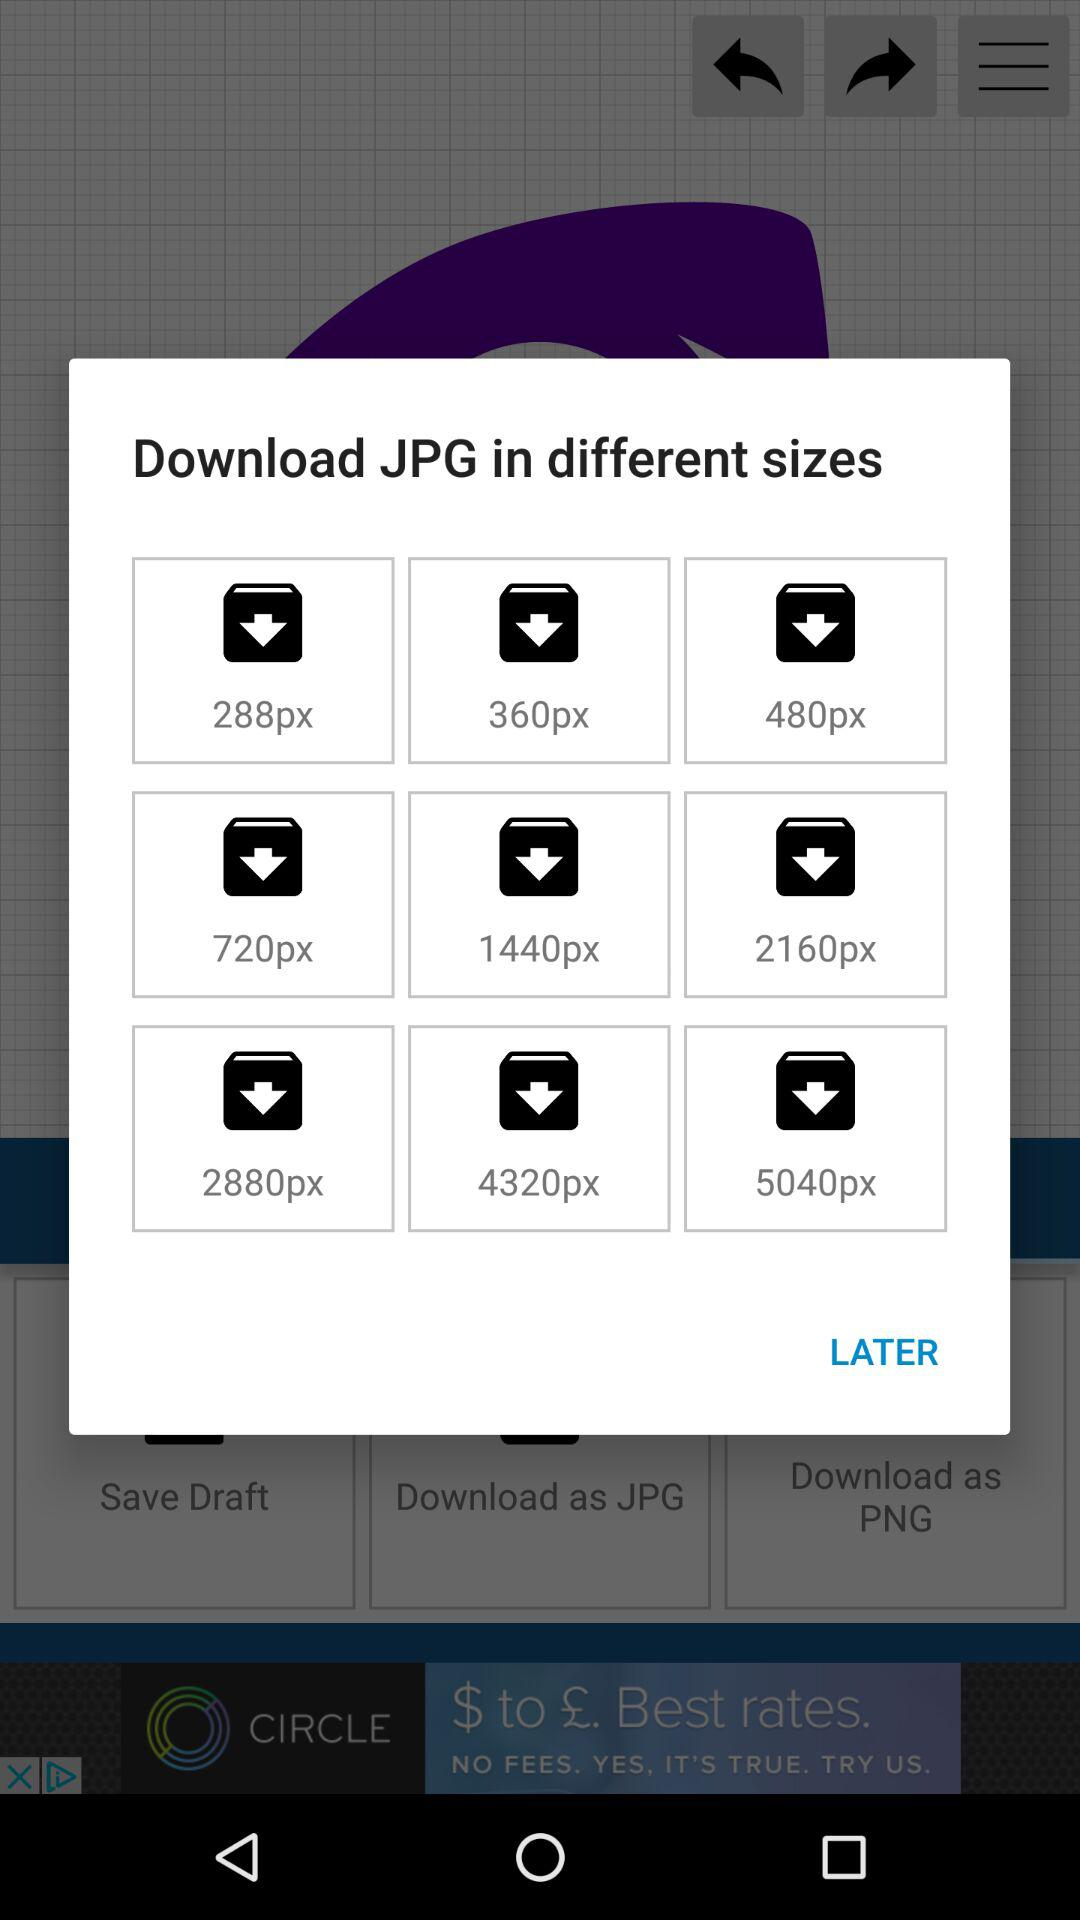What is the largest size of JPG I can download?
Answer the question using a single word or phrase. 5040px 